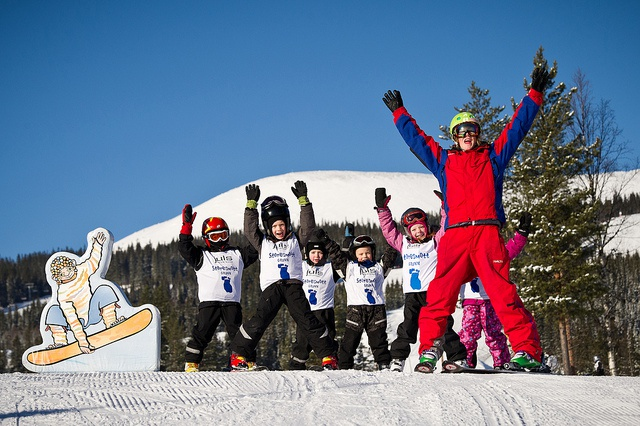Describe the objects in this image and their specific colors. I can see people in blue, red, black, maroon, and navy tones, people in blue, black, white, gray, and darkgray tones, people in blue, black, lightgray, darkgray, and gray tones, people in blue, black, white, gray, and maroon tones, and people in blue, black, white, darkgray, and gray tones in this image. 